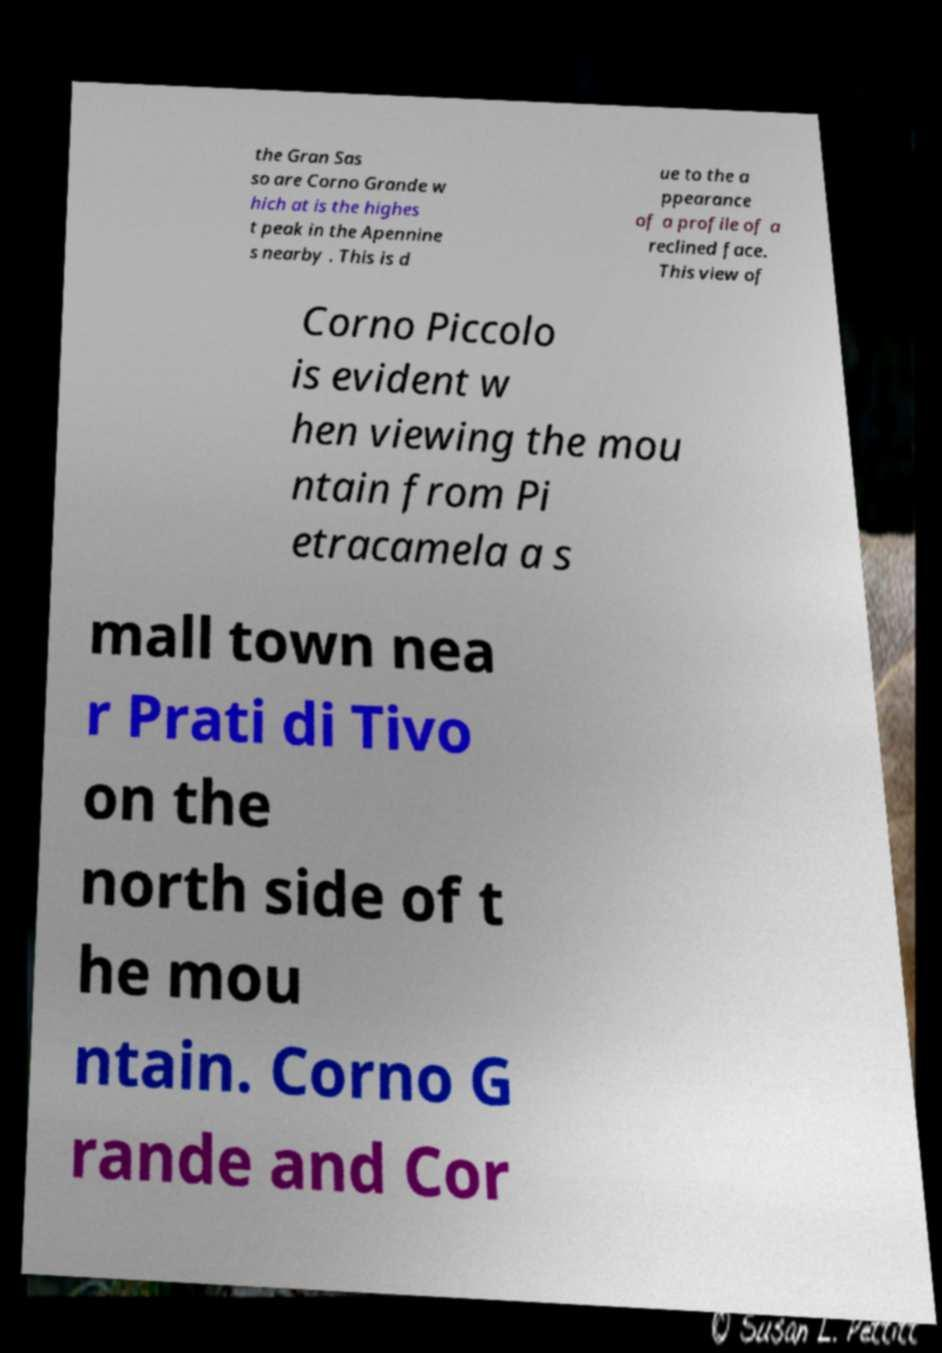Can you accurately transcribe the text from the provided image for me? the Gran Sas so are Corno Grande w hich at is the highes t peak in the Apennine s nearby . This is d ue to the a ppearance of a profile of a reclined face. This view of Corno Piccolo is evident w hen viewing the mou ntain from Pi etracamela a s mall town nea r Prati di Tivo on the north side of t he mou ntain. Corno G rande and Cor 